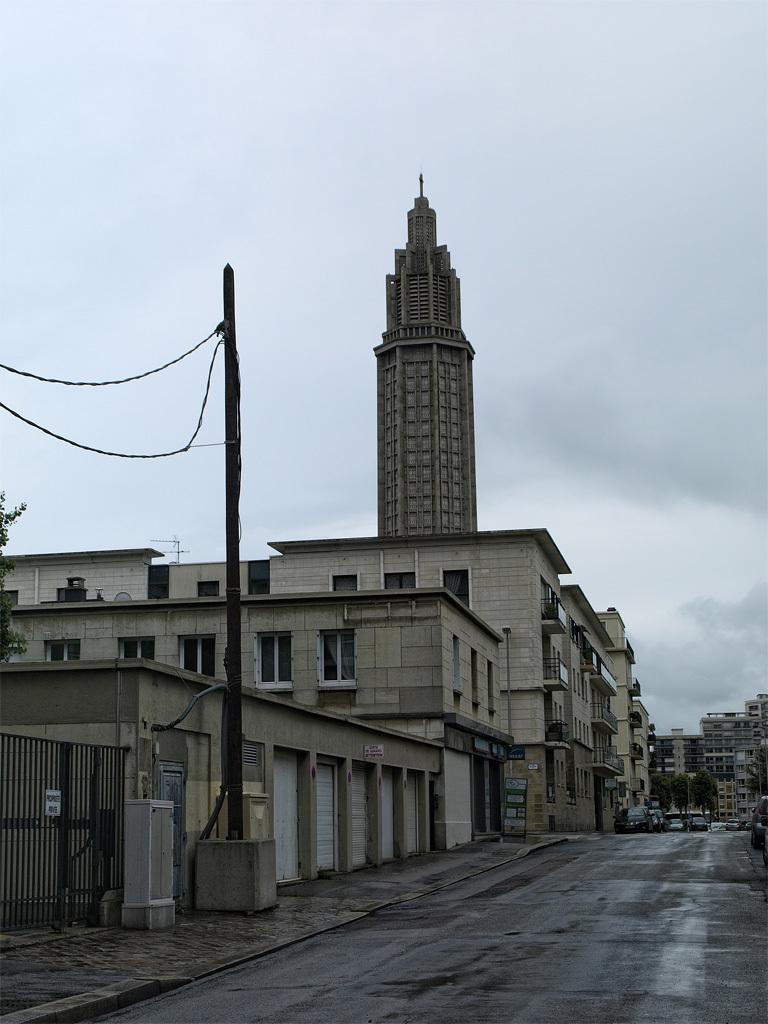Please provide a concise description of this image. To the bottom of the image there is a road. To the left side of the image there is a footpath. Beside the footpath to the left corner there is a gate. Beside the gate there are many stores with shutters. And also there are buildings with windows, walls and pillars. And also there is a pole with wires. In The background to the right side there are buildings and trees. To the top of the image there is a sky with clouds. 